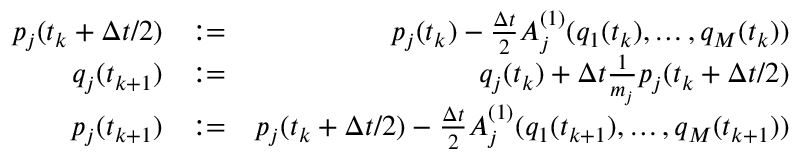Convert formula to latex. <formula><loc_0><loc_0><loc_500><loc_500>\begin{array} { r l r } { p _ { j } ( t _ { k } + \Delta t / 2 ) } & { \colon = } & { p _ { j } ( t _ { k } ) - \frac { \Delta t } { 2 } A _ { j } ^ { ( 1 ) } ( q _ { 1 } ( t _ { k } ) , \dots , q _ { M } ( t _ { k } ) ) } \\ { q _ { j } ( t _ { k + 1 } ) } & { \colon = } & { q _ { j } ( t _ { k } ) + \Delta t \frac { 1 } { m _ { j } } p _ { j } ( t _ { k } + \Delta t / 2 ) } \\ { p _ { j } ( t _ { k + 1 } ) } & { \colon = } & { p _ { j } ( t _ { k } + \Delta t / 2 ) - \frac { \Delta t } { 2 } A _ { j } ^ { ( 1 ) } ( q _ { 1 } ( t _ { k + 1 } ) , \dots , q _ { M } ( t _ { k + 1 } ) ) } \end{array}</formula> 